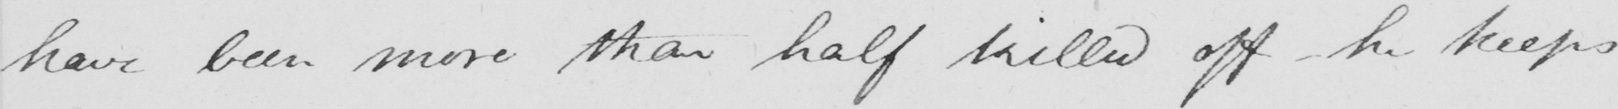Transcribe the text shown in this historical manuscript line. have been more than half killed off  _  he keeps 